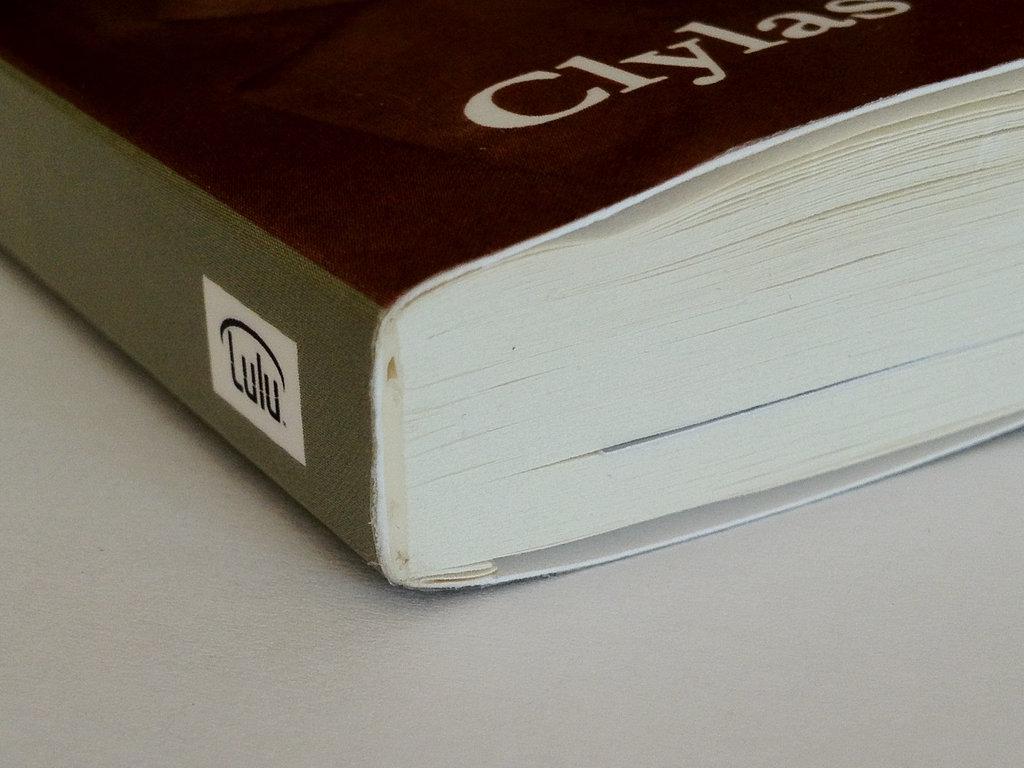Is lulu a book publisher?
Offer a very short reply. Yes. 